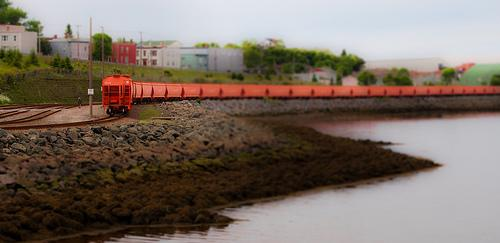Assess the interactions between different objects in the image. The person walking near the train tracks is interacting with the train and the surrounding environment, while the train moves along the tracks passing by trees, rocks, and water. What is in the foreground, and what is in the background? In the foreground, we have a red train on the tracks, a person walking, and a utility pole. In the background, there are buildings, trees, a lake, and other elements. Based on the given information, can you make any inferences about the setting of the image? The image setting appears to be in a countryside or rural area with various elements like a lake, trees, and buildings, suggesting a harmonious blend of nature and human-made structures. Identify the color of the train in the image and its position in the scene. The train is red and positioned on train tracks. Count the number of significant objects mentioned in the image and list them. There are 13 significant objects: red train, caboose, person, wheels, train cars, buildings, rocks, water, trees, utility pole, lake, ledge, and house. Provide a short caption describing the overall scenario in the image. A red train travels along tracks amidst trees, buildings, and water, while a person walks nearby. What is the main object near the train tracks and what is the scene like around it? The main object near the train tracks is a red train, surrounded by trees with green leaves, buildings, and a lake. Discuss the sentiment or mood conveyed by the image. The image conveys a serene and peaceful atmosphere with the train moving through a beautiful, natural environment. Describe the types of objects appearing in the image in terms of color and size. Objects in the image include a red train with varying sizes, black wheels, green trees, a mix of red, and white buildings, as well as a murky lake and other natural elements. Analyze the quality of the image regarding the visibility of objects and the level of detail. The image has high quality with clearly visible objects and a high level of detail, making it easy to identify various elements. Is there a black sign on a pole next to the train tracks? No, it's not mentioned in the image. Can you find a person running near the train tracks? There are mentions of a person walking near the train tracks, but no mention of a person running. 